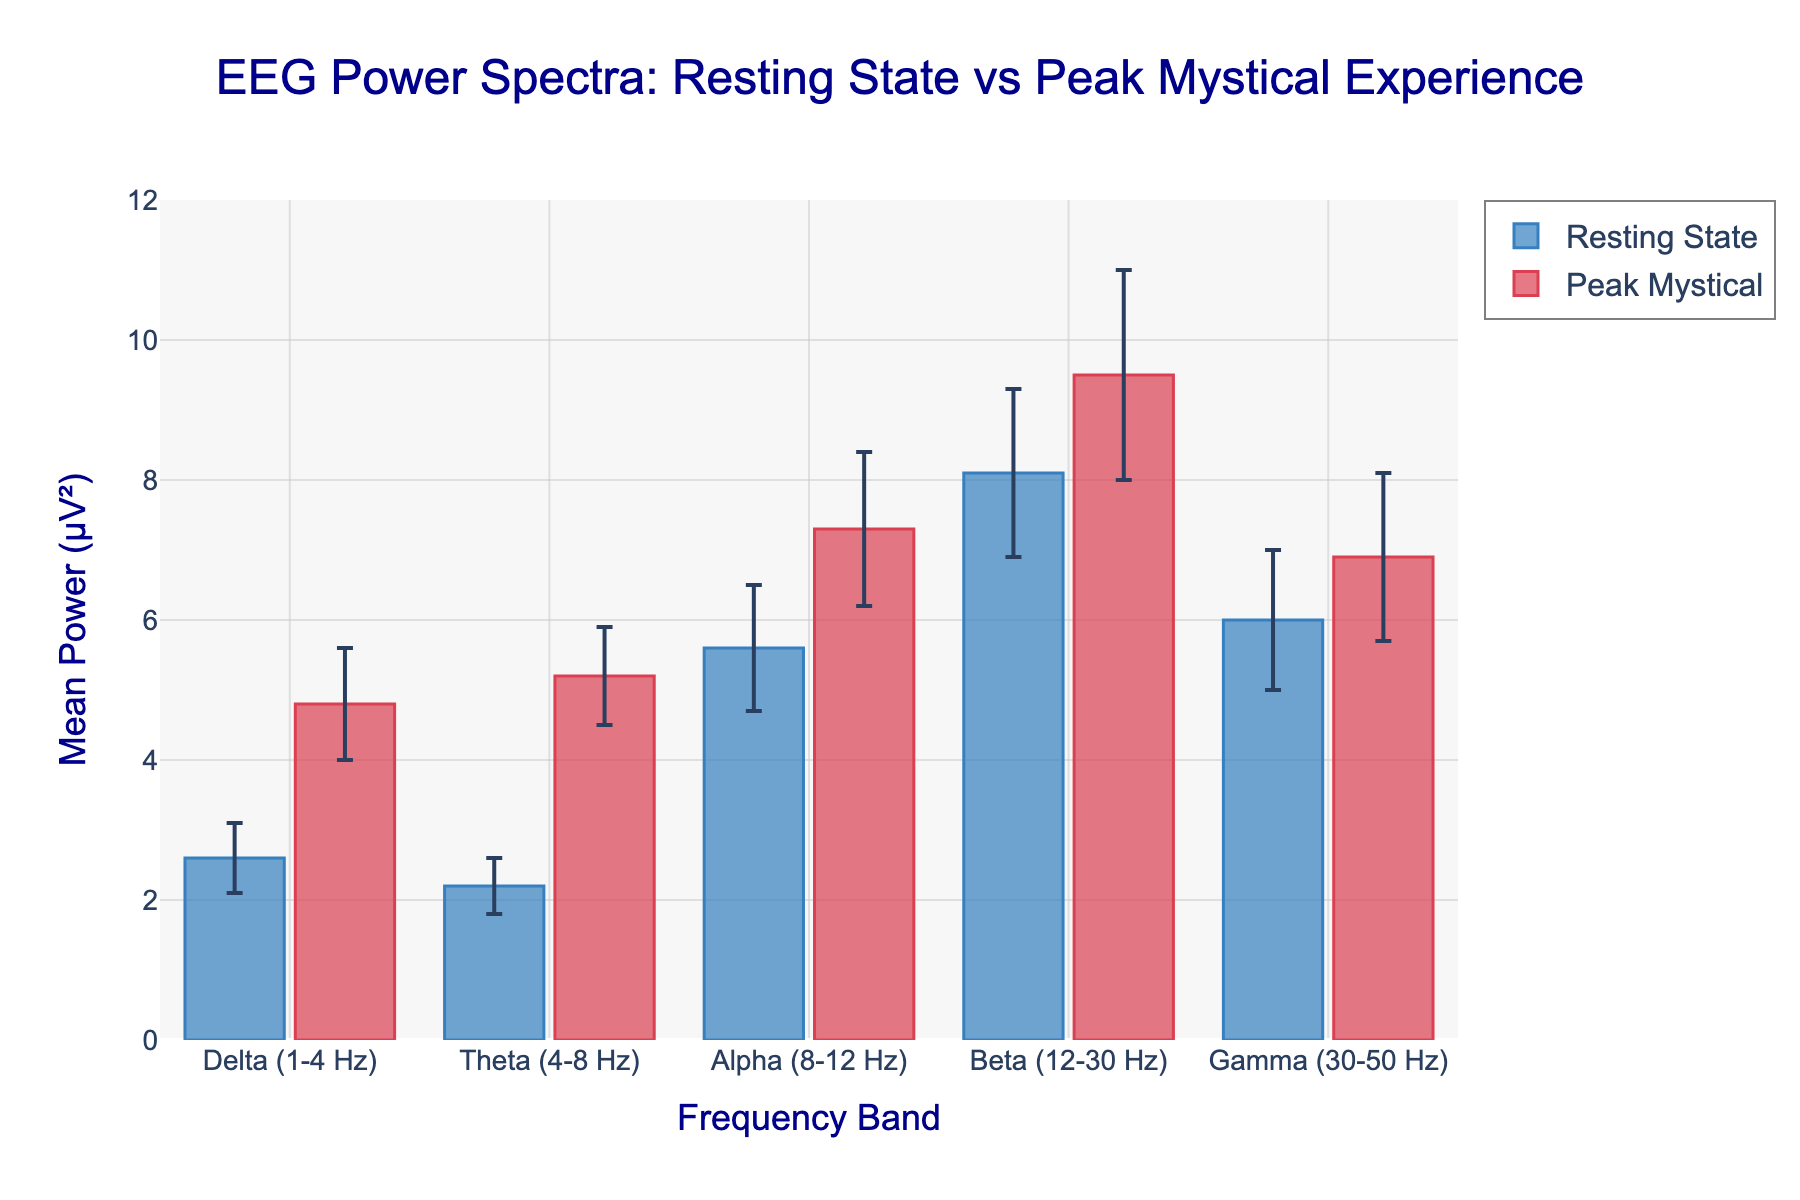what are the mean power values for the delta frequency band for both Resting State and Peak Mystical? Look for the bar heights in the delta frequency category for both conditions. Resting State has a mean power of 2.6 while Peak Mystical has a mean power of 4.8.
Answer: 2.6 and 4.8 which frequency band shows the highest mean power during Peak Mystical experiences? Compare the heights of the bars for Peak Mystical in all frequency bands. The Alpha band has the highest mean power at 7.3.
Answer: Alpha (8-12 Hz) how do the standard deviations for the Resting State vary across frequency bands, and which has the highest variability? Observe the error bars' sizes for Resting State across the frequency bands. The Beta band has the highest standard deviation at 1.2.
Answer: Beta (12-30 Hz) how much higher is the mean power in the Theta band during Peak Mystical experiences compared to Resting State? Subtract the mean power of Resting State from Peak Mystical in the Theta band (5.2 - 2.2).
Answer: 3.0 which frequency band has the smallest difference in mean power between Resting State and Peak Mystical experiences? Calculate the differences for each frequency band and compare them. The Gamma band has the smallest difference (6.9 - 6.0 = 0.9).
Answer: Gamma (30-50 Hz) is there any frequency band where the Resting State and Peak Mystical error bars overlap? Look visually and determine if any error bars for Resting State and Peak Mystical share common regions. In the Gamma band, the error bars overlap.
Answer: Yes, Gamma (30-50 Hz) in the Beta band, are the error bars for Peak Mystical larger or smaller than those for Resting State? Compare the sizes of the error bars in the Beta band. The error bar for Peak Mystical is larger (1.5 compared to 1.2).
Answer: Larger what is the total mean power for all frequency bands combined during Peak Mystical experiences? Sum the mean power values for all frequency bands during Peak Mystical experiences: 4.8 + 5.2 + 7.3 + 9.5 + 6.9.
Answer: 33.7 how does the mean power for Alpha band during Resting State compare to Gamma band during Peak Mystical experiences? Compare the mean power values directly. Alpha during Resting State is 5.6, while Gamma during Peak Mystical is 6.9. Gamma during Peak Mystical is higher.
Answer: Gamma (30-50 Hz) is higher which band’s variability during Peak Mystical experiences is closest to the variability in Resting State for the same band? Compare standard deviations for each frequency band between the two conditions and find the closest pair. Gamma band has 1.2 during Peak Mystical and 1.0 during Resting State, making the difference 0.2 which is the closest.
Answer: Gamma (30-50 Hz) 